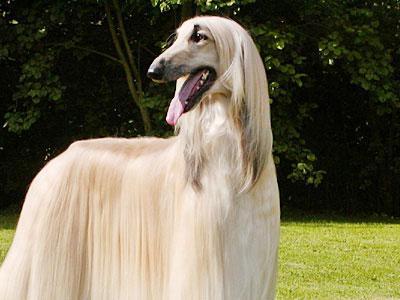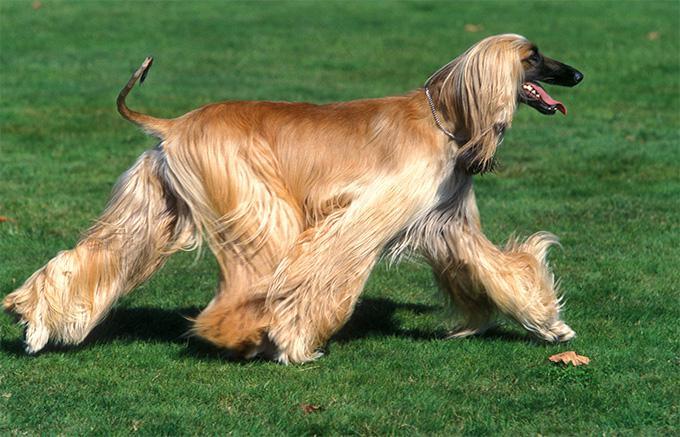The first image is the image on the left, the second image is the image on the right. Assess this claim about the two images: "An image shows exactly one hound standing still outdoors.". Correct or not? Answer yes or no. Yes. The first image is the image on the left, the second image is the image on the right. For the images displayed, is the sentence "There is at least one dog sitting in the image on the left" factually correct? Answer yes or no. No. 